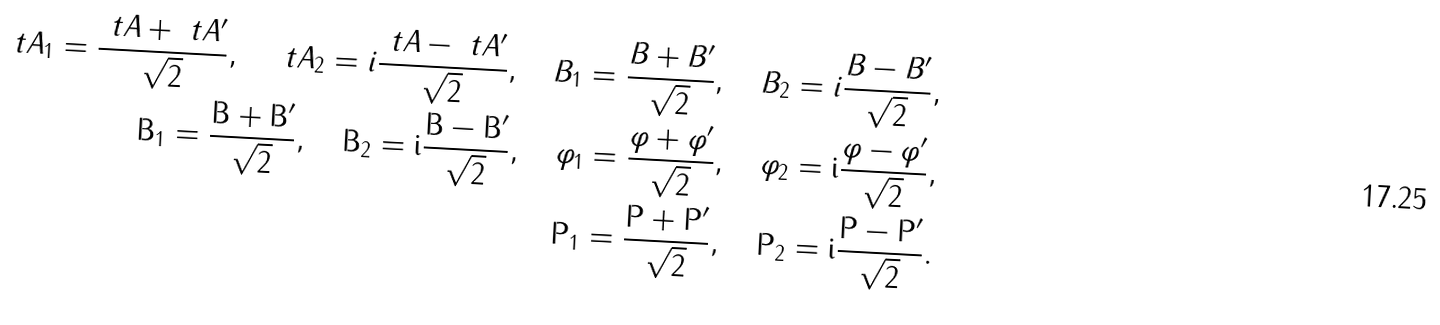<formula> <loc_0><loc_0><loc_500><loc_500>\ t A _ { 1 } = \frac { \ t A + \ t A ^ { \prime } } { \sqrt { 2 } } , \quad \ t A _ { 2 } = i \frac { \ t A - \ t A ^ { \prime } } { \sqrt { 2 } } , \quad B _ { 1 } = \frac { B + B ^ { \prime } } { \sqrt { 2 } } , \quad B _ { 2 } = i \frac { B - B ^ { \prime } } { \sqrt { 2 } } , \\ \tt B _ { 1 } = \frac { \tt B + \tt B ^ { \prime } } { \sqrt { 2 } } , \quad \tt B _ { 2 } = i \frac { \tt B - \tt B ^ { \prime } } { \sqrt { 2 } } , \quad \varphi _ { 1 } = \frac { \varphi + \varphi ^ { \prime } } { \sqrt { 2 } } , \quad \varphi _ { 2 } = i \frac { \varphi - \varphi ^ { \prime } } { \sqrt { 2 } } , \\ \tt P _ { 1 } = \frac { \tt P + \tt P ^ { \prime } } { \sqrt { 2 } } , \quad \tt P _ { 2 } = i \frac { \tt P - \tt P ^ { \prime } } { \sqrt { 2 } } .</formula> 